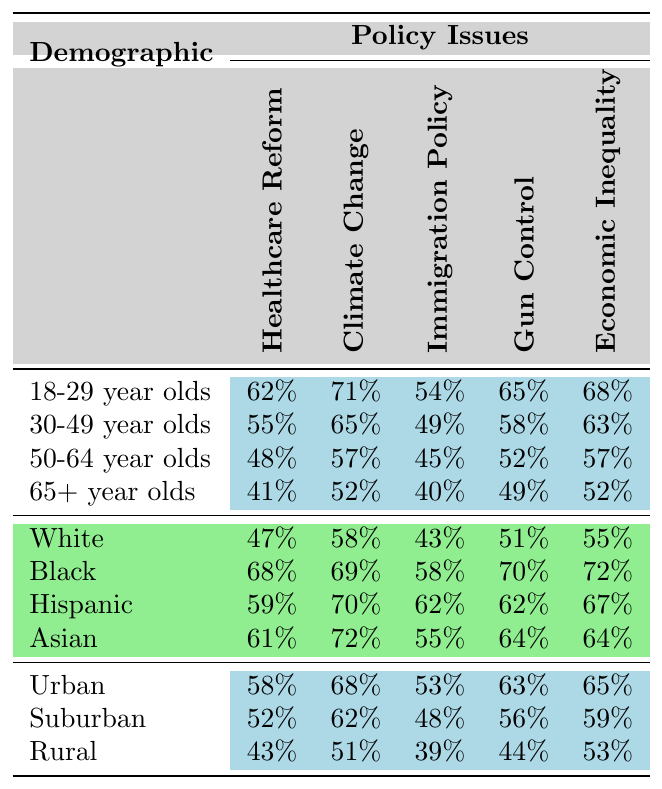What is the approval rating for Healthcare Reform among 18-29 year olds? The table shows that the approval rating for Healthcare Reform in the 18-29 year age group is 62%.
Answer: 62% Which demographic group has the highest approval rating for Climate Change? The highest approval rating for Climate Change is 72%, which is given by the Asian demographic group according to the table.
Answer: Asian What is the difference in approval ratings for Gun Control between 30-49 year olds and 50-64 year olds? The approval rating for Gun Control among 30-49 year olds is 58%, while for 50-64 year olds it is 52%. The difference is 58% - 52% = 6%.
Answer: 6% Is the approval rating for Economic Inequality higher among Rural voters compared to 65+ year olds? The approval rating for Economic Inequality among Rural voters is 53%, while for 65+ year olds it is 52%. Since 53% is greater than 52%, the statement is true.
Answer: Yes What is the average approval rating for Immigration Policy across all age groups? The approval ratings for Immigration Policy among the age groups are 54% (18-29), 49% (30-49), 45% (50-64), and 40% (65+). We sum these values to get 54 + 49 + 45 + 40 = 188. Since there are four age groups, the average is 188 / 4 = 47%.
Answer: 47% Which racial demographic shows the greatest support for Gun Control? The table lists the approval ratings for Gun Control: White 51%, Black 70%, Hispanic 62%, Asian 64%. The highest rating among these groups is from Black voters at 70%.
Answer: Black What is the approval rating for Climate Change among Rural voters, and how does it compare to that of Urban voters? The approval rating for Climate Change among Rural voters is 51%, while for Urban voters it is 68%. The Urban voters have a higher approval by 17%.
Answer: 51%; Urban is higher by 17% For the policy issue of Immigration Policy, which demographic group has the lowest approval rating? The lowest approval rating for Immigration Policy is 39%, which is attributed to Rural voters according to the table.
Answer: Rural What is the overall trend in approval ratings for Economic Inequality from younger to older age groups? The approval ratings for Economic Inequality by age group are 68% (18-29), 63% (30-49), 57% (50-64), and 52% (65+). The trend shows a decline from younger to older age groups.
Answer: Declining trend Are Black voters more supportive of Climate Change policies than White voters? The approval rating for Climate Change among Black voters is 69%, compared to 58% among White voters. Since 69% is greater than 58%, this statement is true.
Answer: Yes 